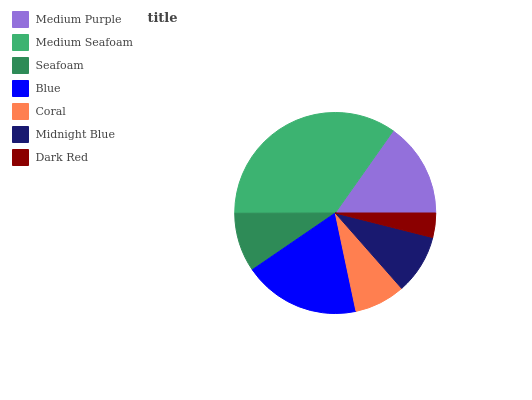Is Dark Red the minimum?
Answer yes or no. Yes. Is Medium Seafoam the maximum?
Answer yes or no. Yes. Is Seafoam the minimum?
Answer yes or no. No. Is Seafoam the maximum?
Answer yes or no. No. Is Medium Seafoam greater than Seafoam?
Answer yes or no. Yes. Is Seafoam less than Medium Seafoam?
Answer yes or no. Yes. Is Seafoam greater than Medium Seafoam?
Answer yes or no. No. Is Medium Seafoam less than Seafoam?
Answer yes or no. No. Is Midnight Blue the high median?
Answer yes or no. Yes. Is Midnight Blue the low median?
Answer yes or no. Yes. Is Medium Purple the high median?
Answer yes or no. No. Is Medium Seafoam the low median?
Answer yes or no. No. 